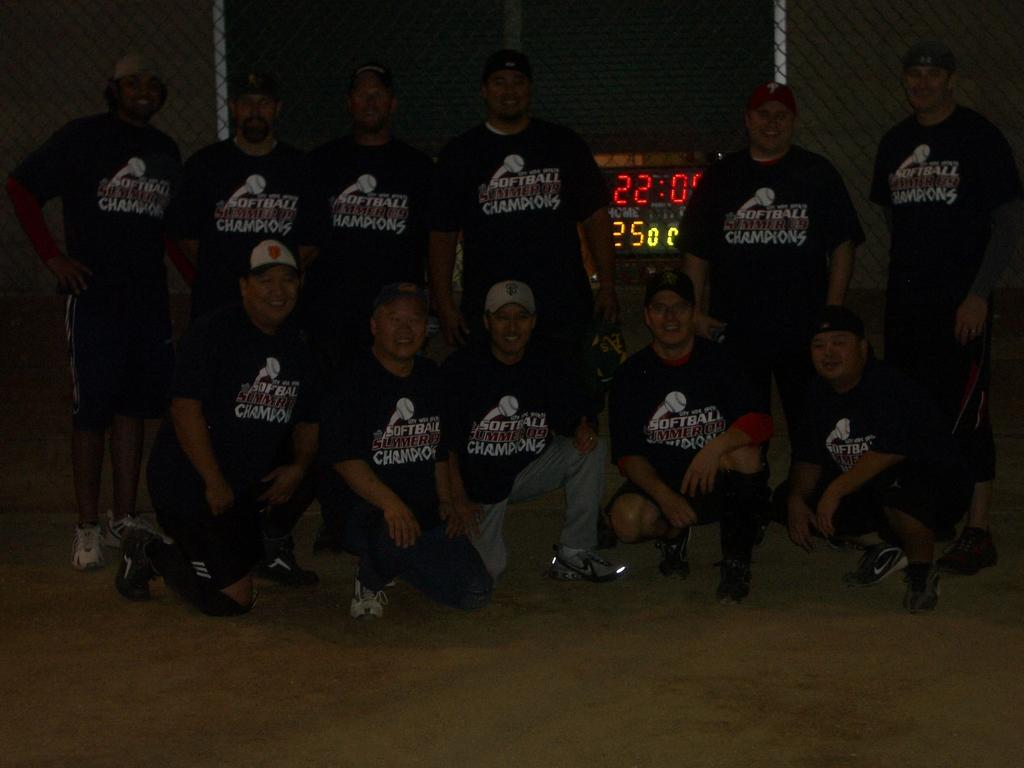Provide a one-sentence caption for the provided image. A group of people wearing shirts saying "Softball champions!" pose for a photo. 